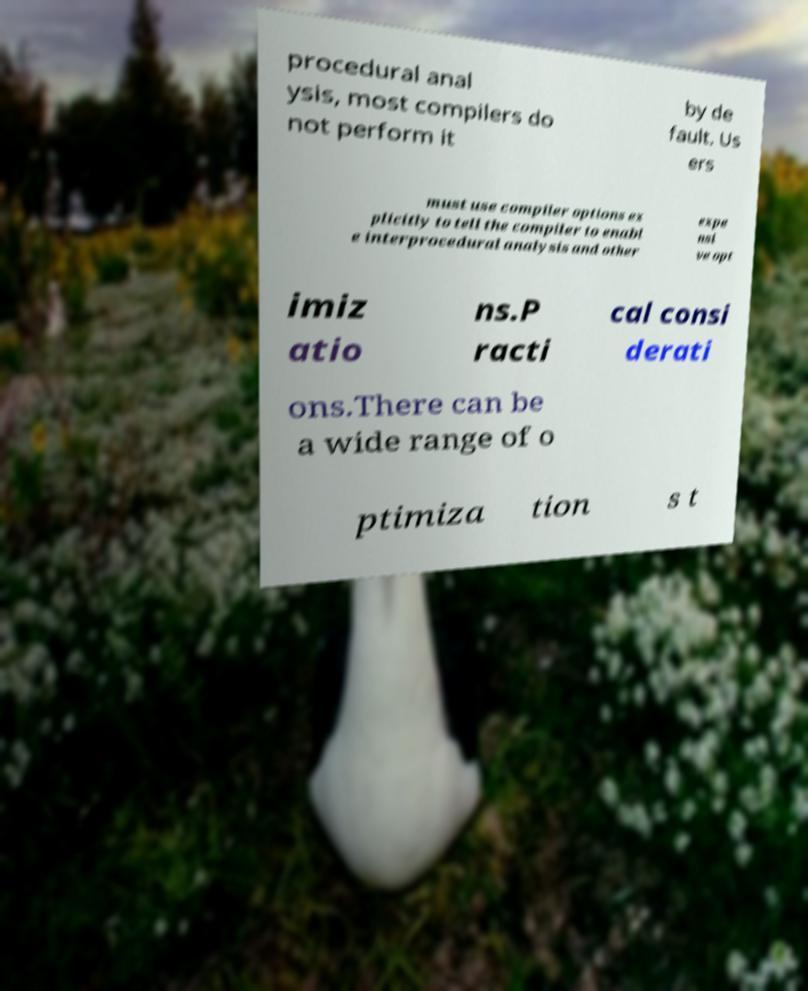Could you assist in decoding the text presented in this image and type it out clearly? procedural anal ysis, most compilers do not perform it by de fault. Us ers must use compiler options ex plicitly to tell the compiler to enabl e interprocedural analysis and other expe nsi ve opt imiz atio ns.P racti cal consi derati ons.There can be a wide range of o ptimiza tion s t 